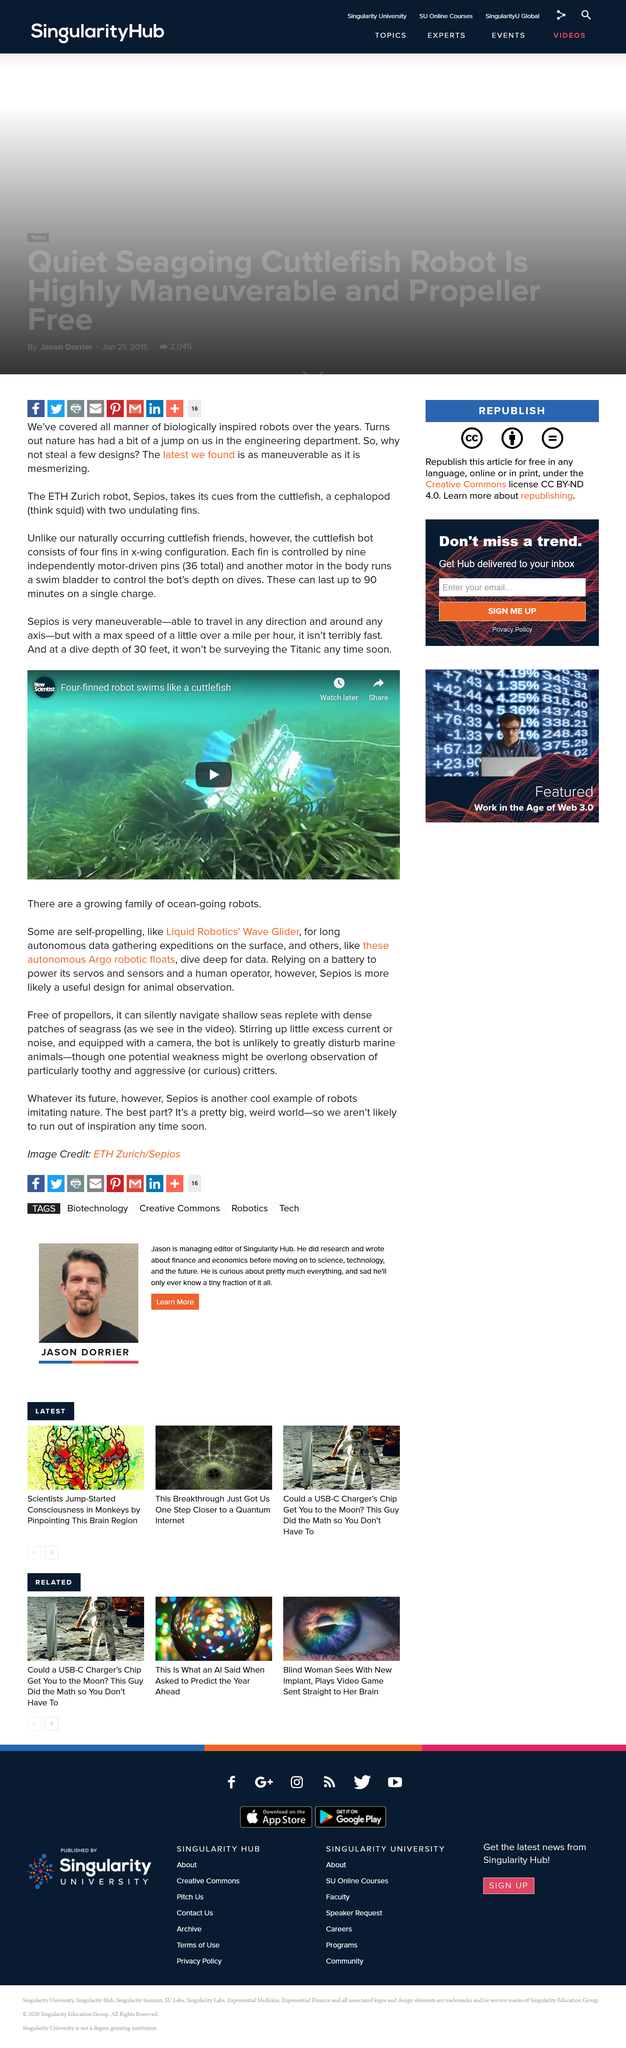Highlight a few significant elements in this photo. Nine independently motor-driven pins control each fin, with every fin being driven by multiple motor-pins. The Sepios has a maximum speed of over a mile per hour, making it an incredibly fast device. The cuttlefish bot is equipped with four fins that are arranged in an x-wing configuration. 